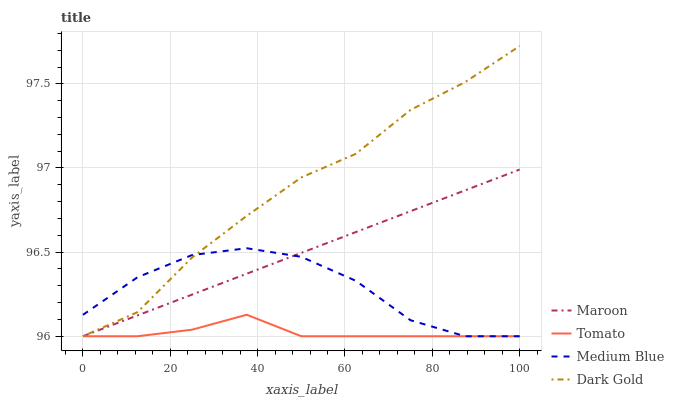Does Tomato have the minimum area under the curve?
Answer yes or no. Yes. Does Dark Gold have the maximum area under the curve?
Answer yes or no. Yes. Does Medium Blue have the minimum area under the curve?
Answer yes or no. No. Does Medium Blue have the maximum area under the curve?
Answer yes or no. No. Is Maroon the smoothest?
Answer yes or no. Yes. Is Medium Blue the roughest?
Answer yes or no. Yes. Is Medium Blue the smoothest?
Answer yes or no. No. Is Maroon the roughest?
Answer yes or no. No. Does Medium Blue have the highest value?
Answer yes or no. No. 